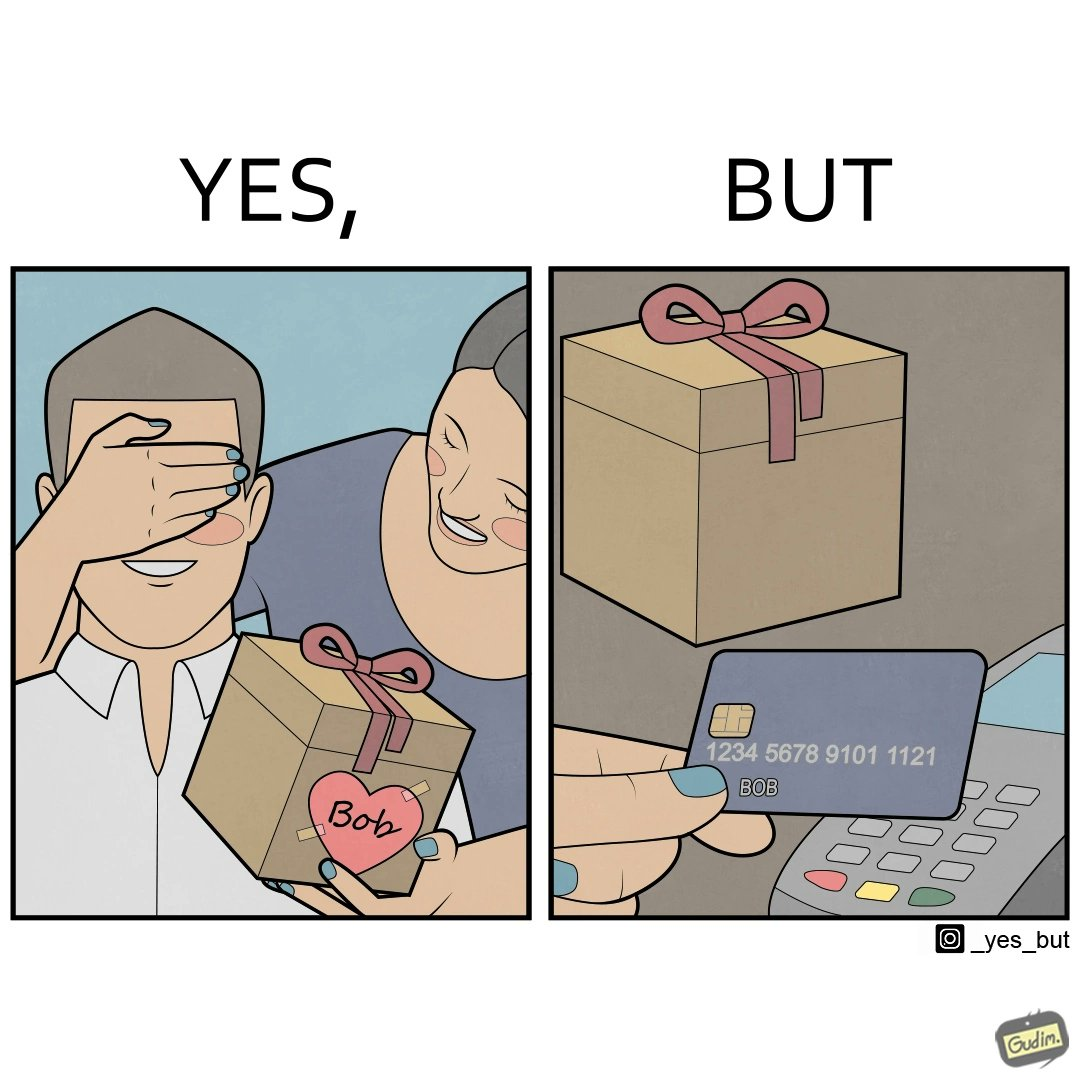What is shown in this image? The image is ironical, as a woman is gifting something to a person named Bob, while using Bob's card itself to purchase the gift. 